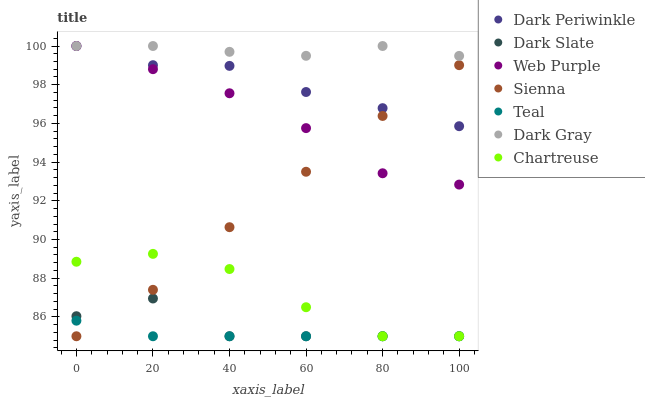Does Teal have the minimum area under the curve?
Answer yes or no. Yes. Does Dark Gray have the maximum area under the curve?
Answer yes or no. Yes. Does Chartreuse have the minimum area under the curve?
Answer yes or no. No. Does Chartreuse have the maximum area under the curve?
Answer yes or no. No. Is Teal the smoothest?
Answer yes or no. Yes. Is Dark Slate the roughest?
Answer yes or no. Yes. Is Chartreuse the smoothest?
Answer yes or no. No. Is Chartreuse the roughest?
Answer yes or no. No. Does Chartreuse have the lowest value?
Answer yes or no. Yes. Does Web Purple have the lowest value?
Answer yes or no. No. Does Dark Periwinkle have the highest value?
Answer yes or no. Yes. Does Chartreuse have the highest value?
Answer yes or no. No. Is Chartreuse less than Web Purple?
Answer yes or no. Yes. Is Dark Periwinkle greater than Dark Slate?
Answer yes or no. Yes. Does Chartreuse intersect Teal?
Answer yes or no. Yes. Is Chartreuse less than Teal?
Answer yes or no. No. Is Chartreuse greater than Teal?
Answer yes or no. No. Does Chartreuse intersect Web Purple?
Answer yes or no. No. 